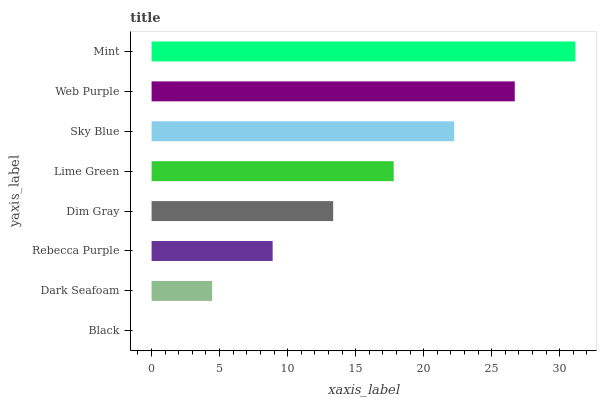Is Black the minimum?
Answer yes or no. Yes. Is Mint the maximum?
Answer yes or no. Yes. Is Dark Seafoam the minimum?
Answer yes or no. No. Is Dark Seafoam the maximum?
Answer yes or no. No. Is Dark Seafoam greater than Black?
Answer yes or no. Yes. Is Black less than Dark Seafoam?
Answer yes or no. Yes. Is Black greater than Dark Seafoam?
Answer yes or no. No. Is Dark Seafoam less than Black?
Answer yes or no. No. Is Lime Green the high median?
Answer yes or no. Yes. Is Dim Gray the low median?
Answer yes or no. Yes. Is Web Purple the high median?
Answer yes or no. No. Is Web Purple the low median?
Answer yes or no. No. 